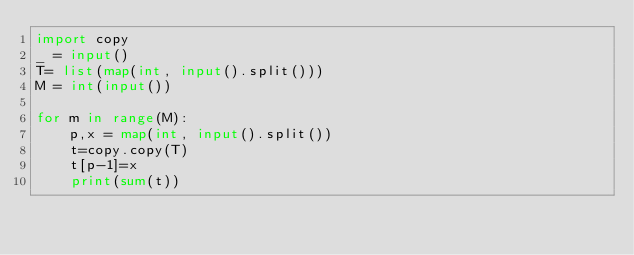Convert code to text. <code><loc_0><loc_0><loc_500><loc_500><_Python_>import copy
_ = input()
T= list(map(int, input().split()))
M = int(input())

for m in range(M):
    p,x = map(int, input().split())
    t=copy.copy(T)
    t[p-1]=x
    print(sum(t))</code> 